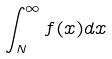Convert formula to latex. <formula><loc_0><loc_0><loc_500><loc_500>\int _ { N } ^ { \infty } f ( x ) d x</formula> 